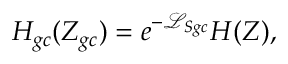Convert formula to latex. <formula><loc_0><loc_0><loc_500><loc_500>H _ { g c } ( Z _ { g c } ) = e ^ { - \mathcal { L } _ { S g c } } H ( Z ) ,</formula> 